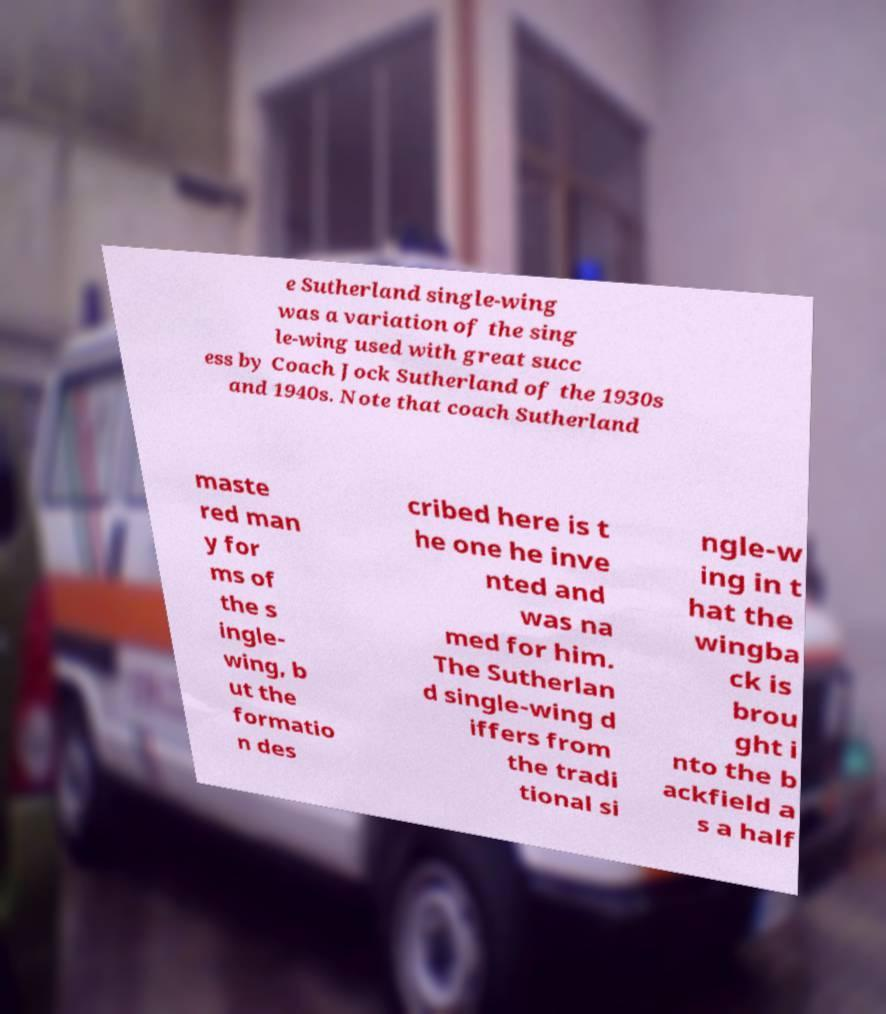Please read and relay the text visible in this image. What does it say? e Sutherland single-wing was a variation of the sing le-wing used with great succ ess by Coach Jock Sutherland of the 1930s and 1940s. Note that coach Sutherland maste red man y for ms of the s ingle- wing, b ut the formatio n des cribed here is t he one he inve nted and was na med for him. The Sutherlan d single-wing d iffers from the tradi tional si ngle-w ing in t hat the wingba ck is brou ght i nto the b ackfield a s a half 